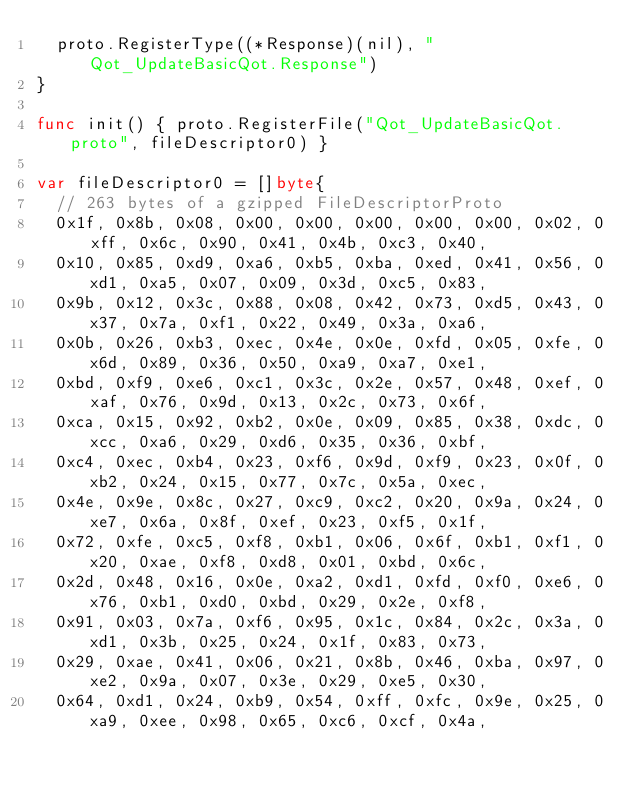<code> <loc_0><loc_0><loc_500><loc_500><_Go_>	proto.RegisterType((*Response)(nil), "Qot_UpdateBasicQot.Response")
}

func init() { proto.RegisterFile("Qot_UpdateBasicQot.proto", fileDescriptor0) }

var fileDescriptor0 = []byte{
	// 263 bytes of a gzipped FileDescriptorProto
	0x1f, 0x8b, 0x08, 0x00, 0x00, 0x00, 0x00, 0x00, 0x02, 0xff, 0x6c, 0x90, 0x41, 0x4b, 0xc3, 0x40,
	0x10, 0x85, 0xd9, 0xa6, 0xb5, 0xba, 0xed, 0x41, 0x56, 0xd1, 0xa5, 0x07, 0x09, 0x3d, 0xc5, 0x83,
	0x9b, 0x12, 0x3c, 0x88, 0x08, 0x42, 0x73, 0xd5, 0x43, 0x37, 0x7a, 0xf1, 0x22, 0x49, 0x3a, 0xa6,
	0x0b, 0x26, 0xb3, 0xec, 0x4e, 0x0e, 0xfd, 0x05, 0xfe, 0x6d, 0x89, 0x36, 0x50, 0xa9, 0xa7, 0xe1,
	0xbd, 0xf9, 0xe6, 0xc1, 0x3c, 0x2e, 0x57, 0x48, 0xef, 0xaf, 0x76, 0x9d, 0x13, 0x2c, 0x73, 0x6f,
	0xca, 0x15, 0x92, 0xb2, 0x0e, 0x09, 0x85, 0x38, 0xdc, 0xcc, 0xa6, 0x29, 0xd6, 0x35, 0x36, 0xbf,
	0xc4, 0xec, 0xb4, 0x23, 0xf6, 0x9d, 0xf9, 0x23, 0x0f, 0xb2, 0x24, 0x15, 0x77, 0x7c, 0x5a, 0xec,
	0x4e, 0x9e, 0x8c, 0x27, 0xc9, 0xc2, 0x20, 0x9a, 0x24, 0xe7, 0x6a, 0x8f, 0xef, 0x23, 0xf5, 0x1f,
	0x72, 0xfe, 0xc5, 0xf8, 0xb1, 0x06, 0x6f, 0xb1, 0xf1, 0x20, 0xae, 0xf8, 0xd8, 0x01, 0xbd, 0x6c,
	0x2d, 0x48, 0x16, 0x0e, 0xa2, 0xd1, 0xfd, 0xf0, 0xe6, 0x76, 0xb1, 0xd0, 0xbd, 0x29, 0x2e, 0xf8,
	0x91, 0x03, 0x7a, 0xf6, 0x95, 0x1c, 0x84, 0x2c, 0x3a, 0xd1, 0x3b, 0x25, 0x24, 0x1f, 0x83, 0x73,
	0x29, 0xae, 0x41, 0x06, 0x21, 0x8b, 0x46, 0xba, 0x97, 0xe2, 0x9a, 0x07, 0x3e, 0x29, 0xe5, 0x30,
	0x64, 0xd1, 0x24, 0xb9, 0x54, 0xff, 0xfc, 0x9e, 0x25, 0xa9, 0xee, 0x98, 0x65, 0xc6, 0xcf, 0x4a,</code> 